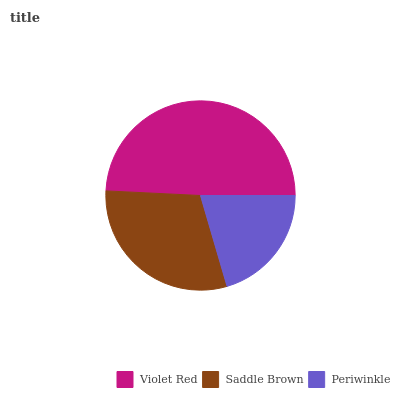Is Periwinkle the minimum?
Answer yes or no. Yes. Is Violet Red the maximum?
Answer yes or no. Yes. Is Saddle Brown the minimum?
Answer yes or no. No. Is Saddle Brown the maximum?
Answer yes or no. No. Is Violet Red greater than Saddle Brown?
Answer yes or no. Yes. Is Saddle Brown less than Violet Red?
Answer yes or no. Yes. Is Saddle Brown greater than Violet Red?
Answer yes or no. No. Is Violet Red less than Saddle Brown?
Answer yes or no. No. Is Saddle Brown the high median?
Answer yes or no. Yes. Is Saddle Brown the low median?
Answer yes or no. Yes. Is Violet Red the high median?
Answer yes or no. No. Is Violet Red the low median?
Answer yes or no. No. 